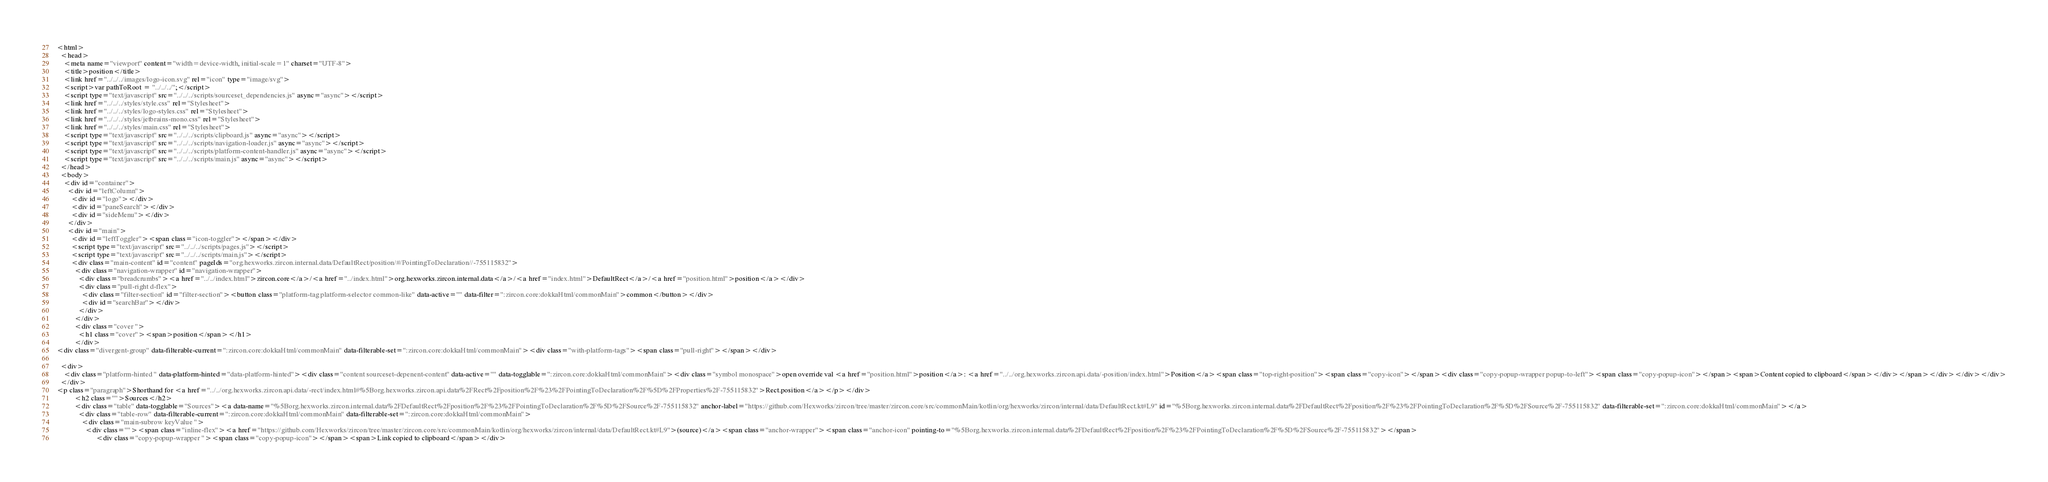Convert code to text. <code><loc_0><loc_0><loc_500><loc_500><_HTML_><html>
  <head>
    <meta name="viewport" content="width=device-width, initial-scale=1" charset="UTF-8">
    <title>position</title>
    <link href="../../../images/logo-icon.svg" rel="icon" type="image/svg">
    <script>var pathToRoot = "../../../";</script>
    <script type="text/javascript" src="../../../scripts/sourceset_dependencies.js" async="async"></script>
    <link href="../../../styles/style.css" rel="Stylesheet">
    <link href="../../../styles/logo-styles.css" rel="Stylesheet">
    <link href="../../../styles/jetbrains-mono.css" rel="Stylesheet">
    <link href="../../../styles/main.css" rel="Stylesheet">
    <script type="text/javascript" src="../../../scripts/clipboard.js" async="async"></script>
    <script type="text/javascript" src="../../../scripts/navigation-loader.js" async="async"></script>
    <script type="text/javascript" src="../../../scripts/platform-content-handler.js" async="async"></script>
    <script type="text/javascript" src="../../../scripts/main.js" async="async"></script>
  </head>
  <body>
    <div id="container">
      <div id="leftColumn">
        <div id="logo"></div>
        <div id="paneSearch"></div>
        <div id="sideMenu"></div>
      </div>
      <div id="main">
        <div id="leftToggler"><span class="icon-toggler"></span></div>
        <script type="text/javascript" src="../../../scripts/pages.js"></script>
        <script type="text/javascript" src="../../../scripts/main.js"></script>
        <div class="main-content" id="content" pageIds="org.hexworks.zircon.internal.data/DefaultRect/position/#/PointingToDeclaration//-755115832">
          <div class="navigation-wrapper" id="navigation-wrapper">
            <div class="breadcrumbs"><a href="../../index.html">zircon.core</a>/<a href="../index.html">org.hexworks.zircon.internal.data</a>/<a href="index.html">DefaultRect</a>/<a href="position.html">position</a></div>
            <div class="pull-right d-flex">
              <div class="filter-section" id="filter-section"><button class="platform-tag platform-selector common-like" data-active="" data-filter=":zircon.core:dokkaHtml/commonMain">common</button></div>
              <div id="searchBar"></div>
            </div>
          </div>
          <div class="cover ">
            <h1 class="cover"><span>position</span></h1>
          </div>
<div class="divergent-group" data-filterable-current=":zircon.core:dokkaHtml/commonMain" data-filterable-set=":zircon.core:dokkaHtml/commonMain"><div class="with-platform-tags"><span class="pull-right"></span></div>

  <div>
    <div class="platform-hinted " data-platform-hinted="data-platform-hinted"><div class="content sourceset-depenent-content" data-active="" data-togglable=":zircon.core:dokkaHtml/commonMain"><div class="symbol monospace">open override val <a href="position.html">position</a>: <a href="../../org.hexworks.zircon.api.data/-position/index.html">Position</a><span class="top-right-position"><span class="copy-icon"></span><div class="copy-popup-wrapper popup-to-left"><span class="copy-popup-icon"></span><span>Content copied to clipboard</span></div></span></div></div></div>
  </div>
<p class="paragraph">Shorthand for <a href="../../org.hexworks.zircon.api.data/-rect/index.html#%5Borg.hexworks.zircon.api.data%2FRect%2Fposition%2F%23%2FPointingToDeclaration%2F%5D%2FProperties%2F-755115832">Rect.position</a></p></div>
          <h2 class="">Sources</h2>
          <div class="table" data-togglable="Sources"><a data-name="%5Borg.hexworks.zircon.internal.data%2FDefaultRect%2Fposition%2F%23%2FPointingToDeclaration%2F%5D%2FSource%2F-755115832" anchor-label="https://github.com/Hexworks/zircon/tree/master/zircon.core/src/commonMain/kotlin/org/hexworks/zircon/internal/data/DefaultRect.kt#L9" id="%5Borg.hexworks.zircon.internal.data%2FDefaultRect%2Fposition%2F%23%2FPointingToDeclaration%2F%5D%2FSource%2F-755115832" data-filterable-set=":zircon.core:dokkaHtml/commonMain"></a>
            <div class="table-row" data-filterable-current=":zircon.core:dokkaHtml/commonMain" data-filterable-set=":zircon.core:dokkaHtml/commonMain">
              <div class="main-subrow keyValue ">
                <div class=""><span class="inline-flex"><a href="https://github.com/Hexworks/zircon/tree/master/zircon.core/src/commonMain/kotlin/org/hexworks/zircon/internal/data/DefaultRect.kt#L9">(source)</a><span class="anchor-wrapper"><span class="anchor-icon" pointing-to="%5Borg.hexworks.zircon.internal.data%2FDefaultRect%2Fposition%2F%23%2FPointingToDeclaration%2F%5D%2FSource%2F-755115832"></span>
                      <div class="copy-popup-wrapper "><span class="copy-popup-icon"></span><span>Link copied to clipboard</span></div></code> 